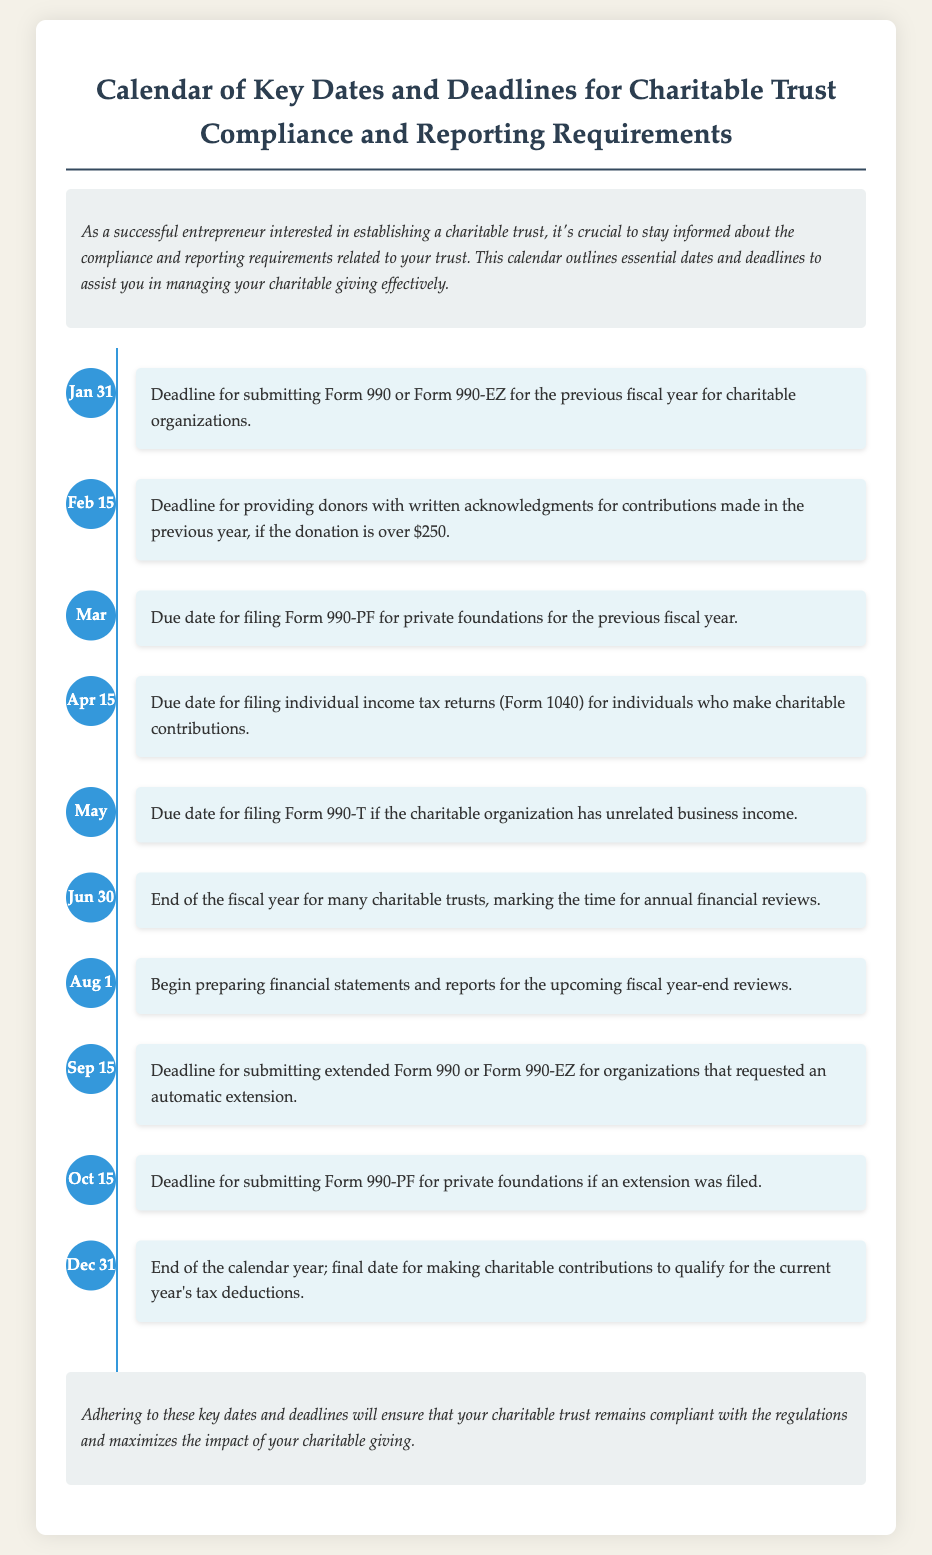What is the first deadline in the calendar? The first deadline listed in the calendar is for submitting Form 990 or Form 990-EZ for the previous fiscal year.
Answer: Jan 31 What must be provided to donors by February 15? The document specifies that donors must receive written acknowledgments for their contributions made in the previous year if the donation is over $250.
Answer: Acknowledgments What is the due date for filing Form 990-PF? Form 990-PF for private foundations is due on March 15 for the previous fiscal year.
Answer: Mar 15 What significant event occurs on June 30? June 30 marks the end of the fiscal year for many charitable trusts, which is significant for annual financial reviews.
Answer: End of the fiscal year When should financial statements be prepared? The calendar indicates that the preparation of financial statements should begin on August 1 for the upcoming fiscal year-end reviews.
Answer: Aug 1 What is the final date for charitable contributions to qualify for tax deductions? The final date to make charitable contributions to qualify for the current year's tax deductions is December 31.
Answer: Dec 31 How many events are listed in the timeline? The document outlines a total of ten key dates and deadlines for charitable trust compliance.
Answer: Ten What type of organization is Form 990-T associated with? Form 990-T must be filed by charitable organizations that have unrelated business income.
Answer: Charitable organizations What does the introduction emphasize? The introduction emphasizes the importance of staying informed about compliance and reporting requirements related to charitable trusts.
Answer: Importance of compliance and reporting 